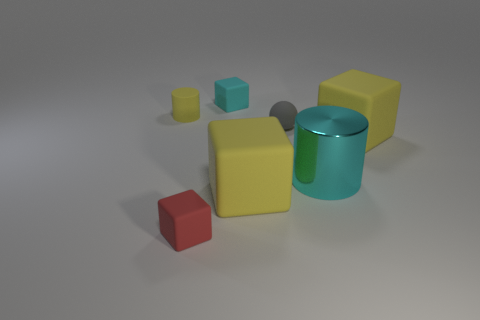Subtract all tiny red blocks. How many blocks are left? 3 Add 2 large matte blocks. How many objects exist? 9 Subtract all red blocks. How many blocks are left? 3 Subtract all red spheres. How many yellow cubes are left? 2 Subtract all cylinders. How many objects are left? 5 Subtract 2 cubes. How many cubes are left? 2 Subtract all small cyan cubes. Subtract all yellow cubes. How many objects are left? 4 Add 5 cyan matte things. How many cyan matte things are left? 6 Add 5 small things. How many small things exist? 9 Subtract 0 green cylinders. How many objects are left? 7 